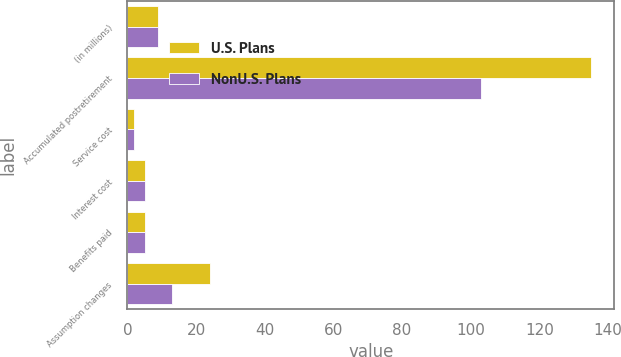Convert chart to OTSL. <chart><loc_0><loc_0><loc_500><loc_500><stacked_bar_chart><ecel><fcel>(in millions)<fcel>Accumulated postretirement<fcel>Service cost<fcel>Interest cost<fcel>Benefits paid<fcel>Assumption changes<nl><fcel>U.S. Plans<fcel>9<fcel>135<fcel>2<fcel>5<fcel>5<fcel>24<nl><fcel>NonU.S. Plans<fcel>9<fcel>103<fcel>2<fcel>5<fcel>5<fcel>13<nl></chart> 